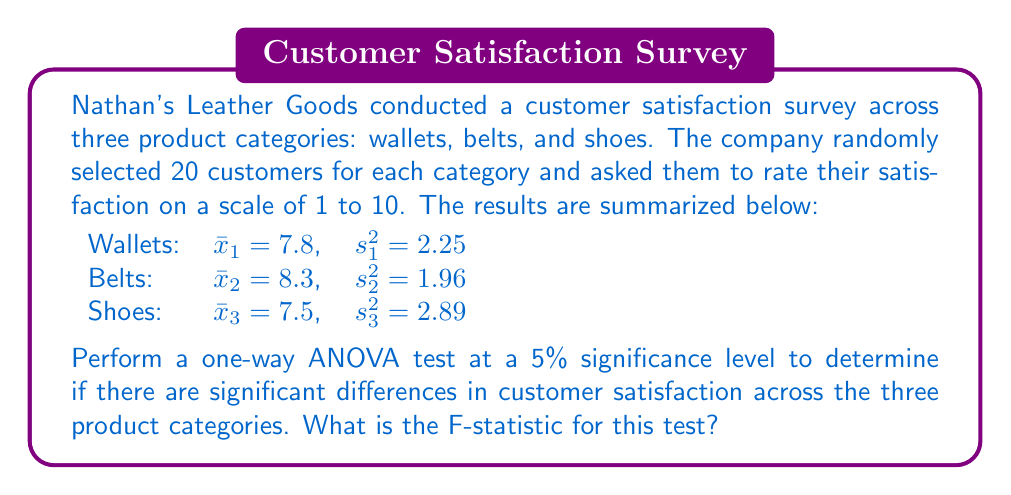Give your solution to this math problem. To perform a one-way ANOVA test, we need to calculate the F-statistic. The steps are as follows:

1. Calculate the Sum of Squares Between (SSB):
   $$SSB = n\sum_{i=1}^k (\bar{x}_i - \bar{x})^2$$
   where $n$ is the number of observations per group, $k$ is the number of groups, $\bar{x}_i$ is the mean of each group, and $\bar{x}$ is the grand mean.

2. Calculate the Sum of Squares Within (SSW):
   $$SSW = (n-1)\sum_{i=1}^k s_i^2$$
   where $s_i^2$ is the variance of each group.

3. Calculate the degrees of freedom:
   $$df_{between} = k - 1$$
   $$df_{within} = k(n-1)$$

4. Calculate the Mean Square Between (MSB) and Mean Square Within (MSW):
   $$MSB = \frac{SSB}{df_{between}}$$
   $$MSW = \frac{SSW}{df_{within}}$$

5. Calculate the F-statistic:
   $$F = \frac{MSB}{MSW}$$

Let's perform these calculations:

1. Grand mean: $\bar{x} = \frac{7.8 + 8.3 + 7.5}{3} = 7.87$
   
   $SSB = 20[(7.8 - 7.87)^2 + (8.3 - 7.87)^2 + (7.5 - 7.87)^2] = 6.42$

2. $SSW = 19(2.25 + 1.96 + 2.89) = 134.9$

3. $df_{between} = 3 - 1 = 2$
   $df_{within} = 3(20-1) = 57$

4. $MSB = \frac{6.42}{2} = 3.21$
   $MSW = \frac{134.9}{57} = 2.37$

5. $F = \frac{3.21}{2.37} = 1.35$

Therefore, the F-statistic for this test is 1.35.
Answer: The F-statistic for the one-way ANOVA test is 1.35. 